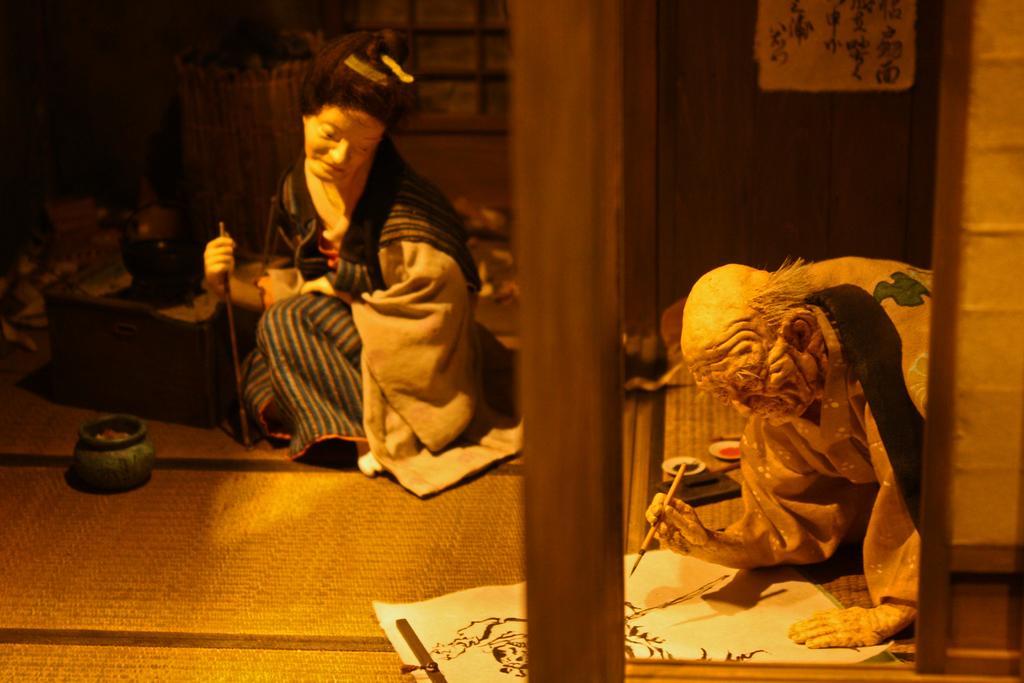Please provide a concise description of this image. In this picture I can see two statues, on the left side it looks like a pot. At the bottom there is a paper with a painting. 